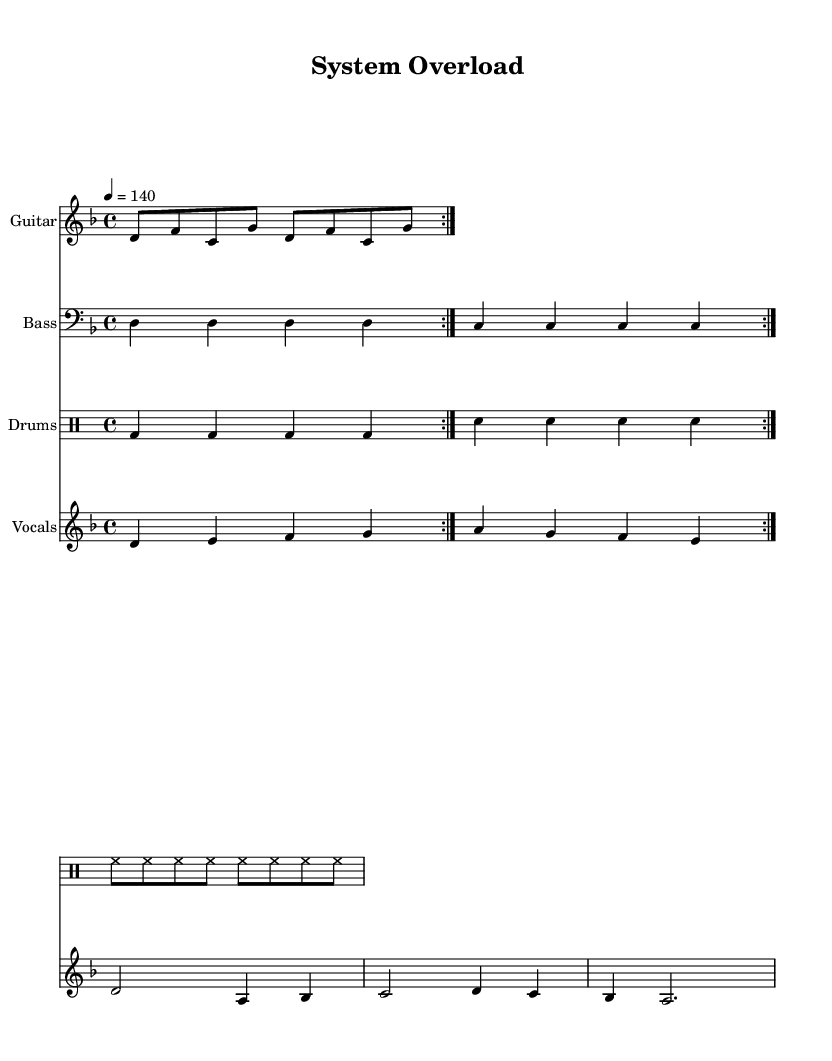What is the key signature of this music? The key signature is indicated at the beginning of the score. It shows two flats, which means the music is in D minor.
Answer: D minor What is the time signature of this music? The time signature, visible right after the key signature, indicates that the music is in 4/4 time, meaning there are four beats per measure.
Answer: 4/4 What is the tempo marking for this song? The tempo marking is provided as '4 = 140', denoting the quarter note gets 140 beats per minute.
Answer: 140 How many measures are in the vocal verse? The vocal verse consists of 4 measures, as counted from the notation that follows the vocal part and the repetition indicated.
Answer: 4 What instruments are featured in this composition? The score clearly lists Guitar, Bass, Drums, and Vocals as the instruments included in the piece.
Answer: Guitar, Bass, Drums, Vocals Which lyric captures the theme of frustration with bureaucracy? The lyrics "Trapped in a maze of red tape and lies" succinctly express frustration with bureaucratic obstacles.
Answer: Trapped in a maze of red tape and lies What is the title of this music? The title is positioned at the top of the score and is clearly labeled as "System Overload".
Answer: System Overload 